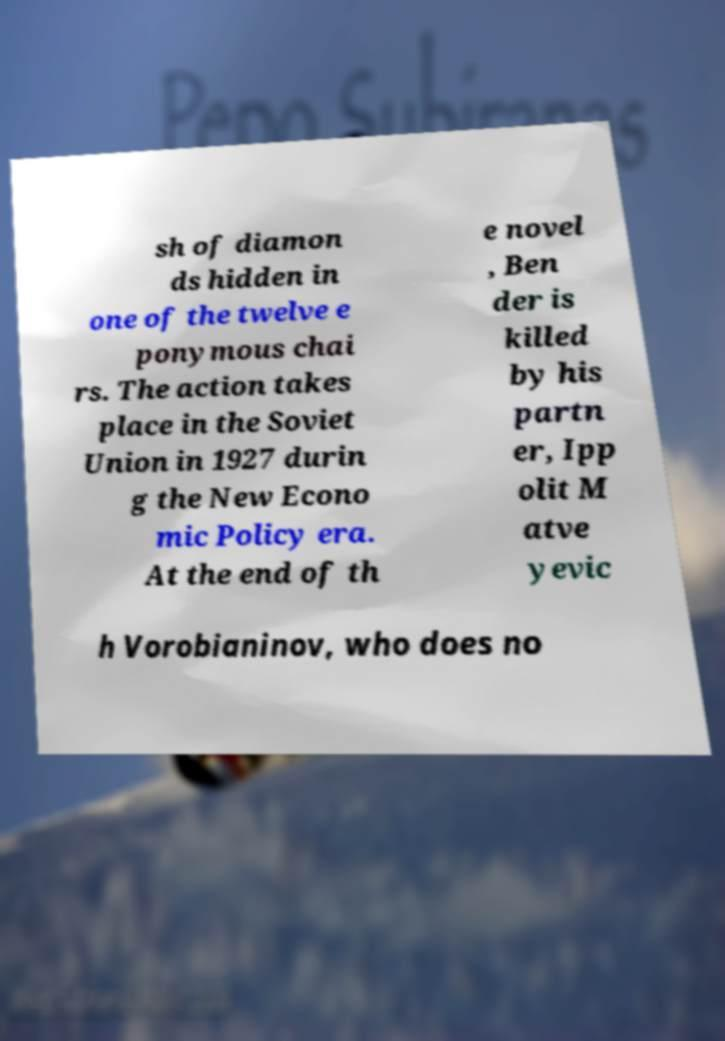What messages or text are displayed in this image? I need them in a readable, typed format. sh of diamon ds hidden in one of the twelve e ponymous chai rs. The action takes place in the Soviet Union in 1927 durin g the New Econo mic Policy era. At the end of th e novel , Ben der is killed by his partn er, Ipp olit M atve yevic h Vorobianinov, who does no 